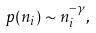<formula> <loc_0><loc_0><loc_500><loc_500>p ( n _ { i } ) \sim n _ { i } ^ { - \gamma } ,</formula> 